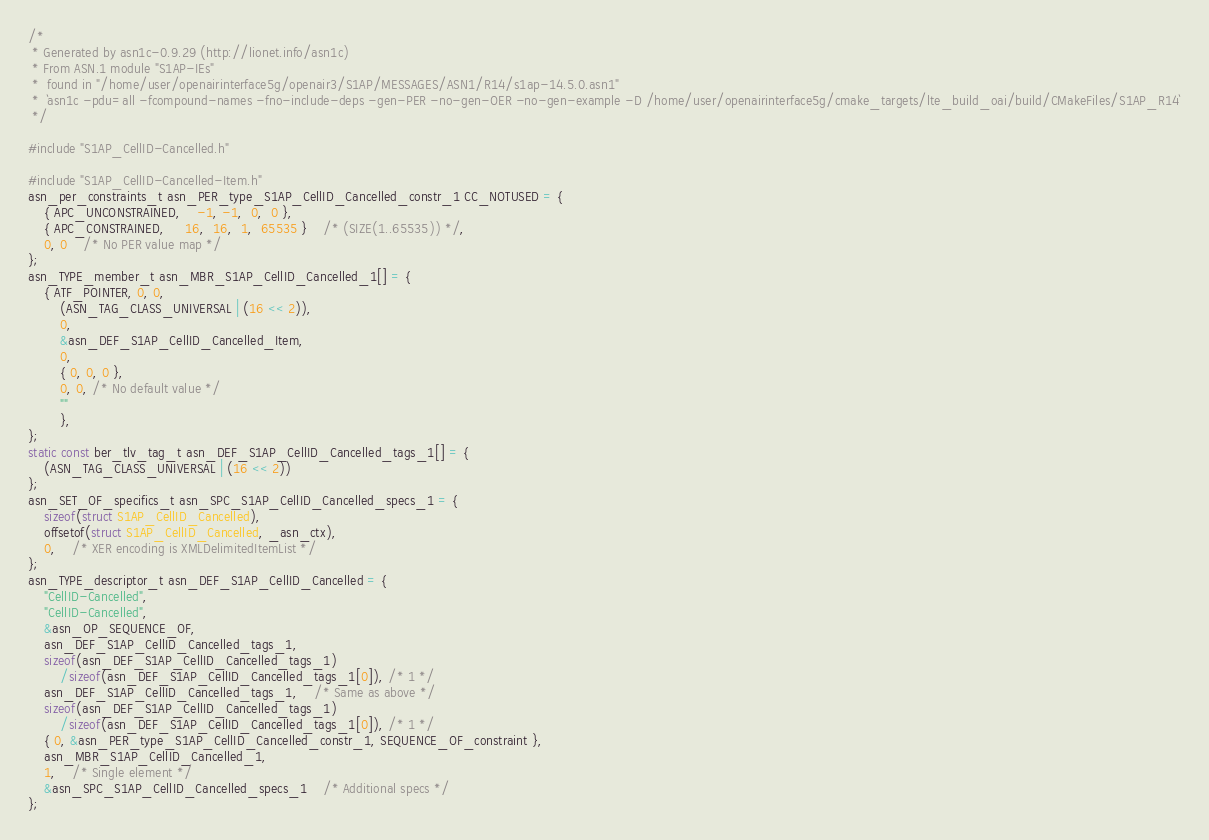Convert code to text. <code><loc_0><loc_0><loc_500><loc_500><_C_>/*
 * Generated by asn1c-0.9.29 (http://lionet.info/asn1c)
 * From ASN.1 module "S1AP-IEs"
 * 	found in "/home/user/openairinterface5g/openair3/S1AP/MESSAGES/ASN1/R14/s1ap-14.5.0.asn1"
 * 	`asn1c -pdu=all -fcompound-names -fno-include-deps -gen-PER -no-gen-OER -no-gen-example -D /home/user/openairinterface5g/cmake_targets/lte_build_oai/build/CMakeFiles/S1AP_R14`
 */

#include "S1AP_CellID-Cancelled.h"

#include "S1AP_CellID-Cancelled-Item.h"
asn_per_constraints_t asn_PER_type_S1AP_CellID_Cancelled_constr_1 CC_NOTUSED = {
	{ APC_UNCONSTRAINED,	-1, -1,  0,  0 },
	{ APC_CONSTRAINED,	 16,  16,  1,  65535 }	/* (SIZE(1..65535)) */,
	0, 0	/* No PER value map */
};
asn_TYPE_member_t asn_MBR_S1AP_CellID_Cancelled_1[] = {
	{ ATF_POINTER, 0, 0,
		(ASN_TAG_CLASS_UNIVERSAL | (16 << 2)),
		0,
		&asn_DEF_S1AP_CellID_Cancelled_Item,
		0,
		{ 0, 0, 0 },
		0, 0, /* No default value */
		""
		},
};
static const ber_tlv_tag_t asn_DEF_S1AP_CellID_Cancelled_tags_1[] = {
	(ASN_TAG_CLASS_UNIVERSAL | (16 << 2))
};
asn_SET_OF_specifics_t asn_SPC_S1AP_CellID_Cancelled_specs_1 = {
	sizeof(struct S1AP_CellID_Cancelled),
	offsetof(struct S1AP_CellID_Cancelled, _asn_ctx),
	0,	/* XER encoding is XMLDelimitedItemList */
};
asn_TYPE_descriptor_t asn_DEF_S1AP_CellID_Cancelled = {
	"CellID-Cancelled",
	"CellID-Cancelled",
	&asn_OP_SEQUENCE_OF,
	asn_DEF_S1AP_CellID_Cancelled_tags_1,
	sizeof(asn_DEF_S1AP_CellID_Cancelled_tags_1)
		/sizeof(asn_DEF_S1AP_CellID_Cancelled_tags_1[0]), /* 1 */
	asn_DEF_S1AP_CellID_Cancelled_tags_1,	/* Same as above */
	sizeof(asn_DEF_S1AP_CellID_Cancelled_tags_1)
		/sizeof(asn_DEF_S1AP_CellID_Cancelled_tags_1[0]), /* 1 */
	{ 0, &asn_PER_type_S1AP_CellID_Cancelled_constr_1, SEQUENCE_OF_constraint },
	asn_MBR_S1AP_CellID_Cancelled_1,
	1,	/* Single element */
	&asn_SPC_S1AP_CellID_Cancelled_specs_1	/* Additional specs */
};

</code> 